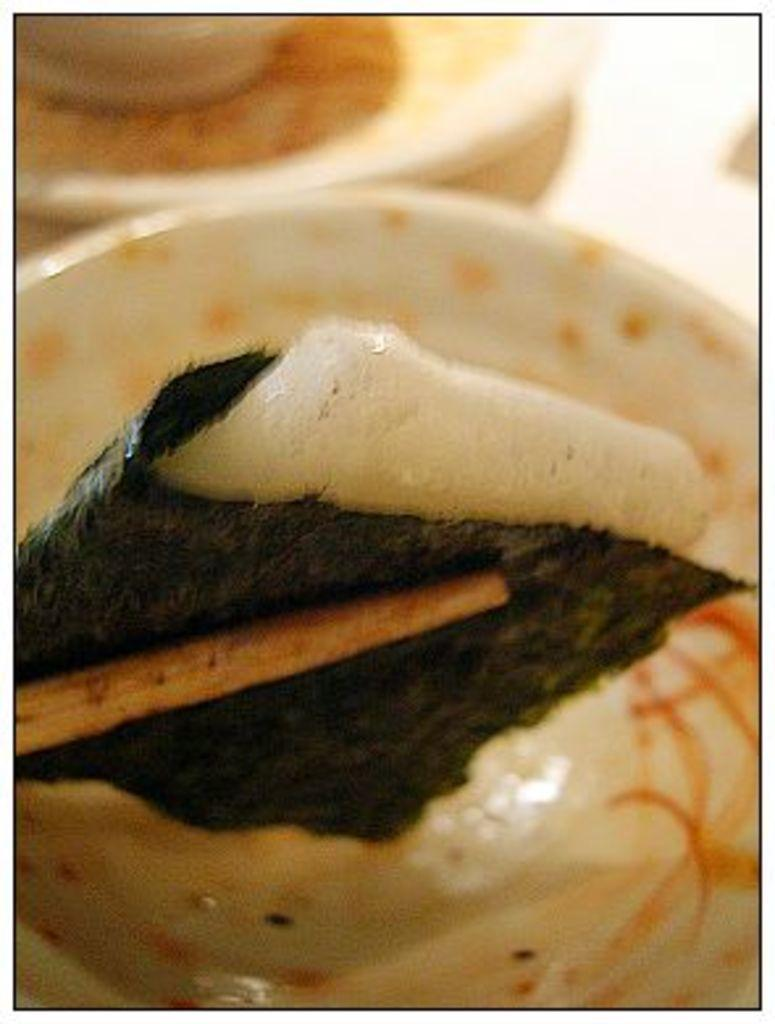What type of food can be seen in the image? There is food in the image, but the specific type is not mentioned. What utensils are present in the image? Chopsticks are present in the image. What can be seen in the background of the image? There is a group of plates and a bowl placed on a surface in the background of the image. What type of cup can be seen in the image? There is no cup present in the image. 